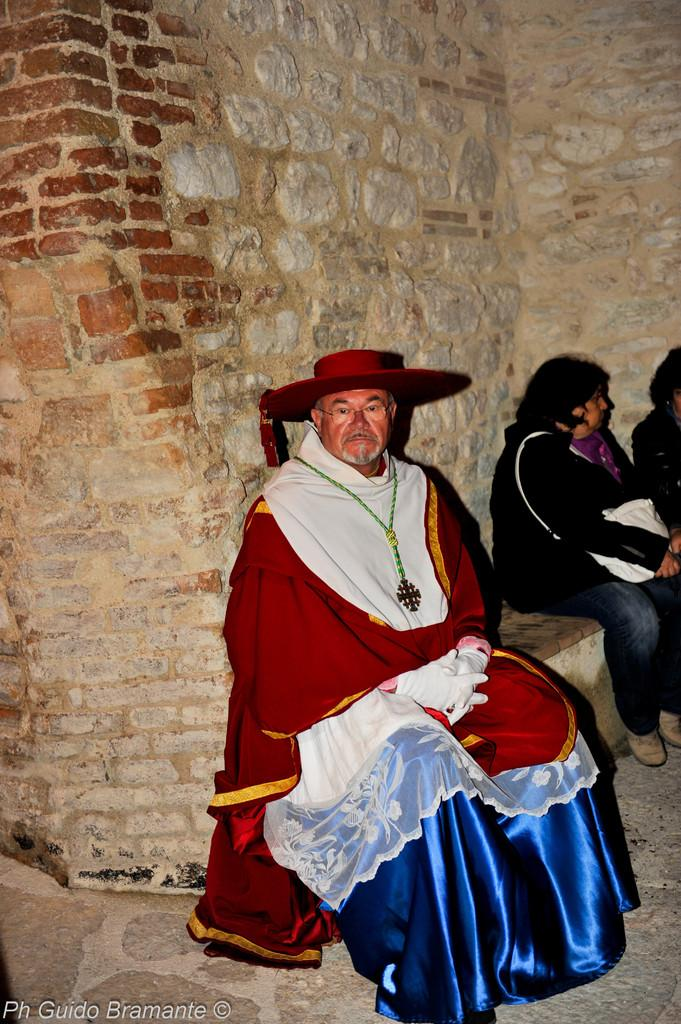How many people are in the image? There is a group of people in the image. What are the people doing in the image? The people are sitting on a bench. What can be seen in the background of the image? There is a wall in the background of the image. Is there any additional information about the image itself? Yes, there is a watermark on the image. What type of jam is being served to the people in the image? There is no jam present in the image; the people are sitting on a bench and there is no indication of food or drink being served. 